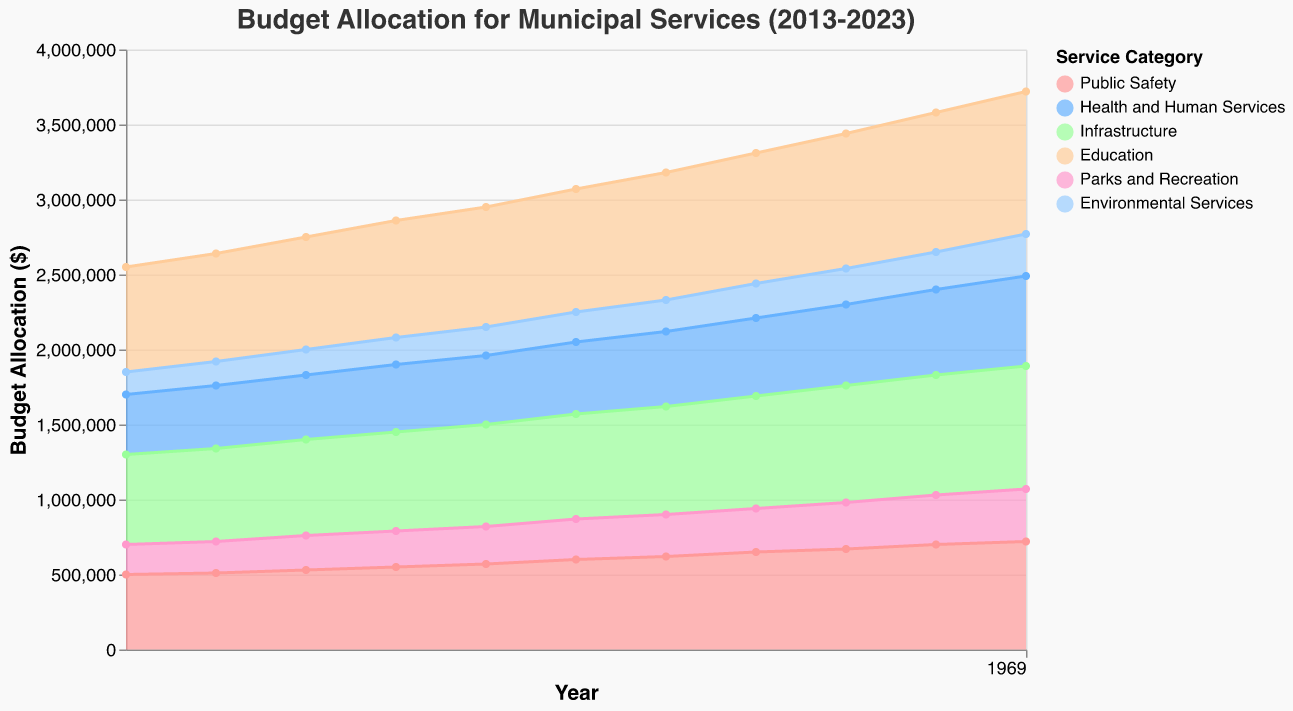What is the title of the figure? The title of the figure is at the top and describes the overall content of the chart. It reads "Budget Allocation for Municipal Services (2013-2023)" which provides context for what the chart represents.
Answer: Budget Allocation for Municipal Services (2013-2023) What are the six categories of services represented in the chart? The legend in the chart details the six different categories being plotted, which are: Public Safety, Health and Human Services, Infrastructure, Education, Parks and Recreation, and Environmental Services.
Answer: Public Safety, Health and Human Services, Infrastructure, Education, Parks and Recreation, Environmental Services In which year does 'Education' have the highest budget? By following the 'Education' area in the chart, it is visible that 'Education' has the largest budget allocation in the year 2023, where its area is maximized.
Answer: 2023 What is the total budget allocation for 'Public Safety' and 'Health and Human Services' in the year 2018? Refer to the values given for 'Public Safety' and 'Health and Human Services' in 2018 and sum them up: $600,000 for 'Public Safety' and $480,000 for 'Health and Human Services'. Therefore, the total allocation is $600,000 + $480,000 = $1,080,000.
Answer: $1,080,000 Which category has the largest budget allocation in 2015? By examining the heights of the different colored areas starting from the y-axis for the year 2015 and moving rightwards, it can be seen that 'Education' (orange color) has the highest area, indicating the largest budget allocation.
Answer: Education How has the budget for 'Environmental Services' changed from 2013 to 2023? By comparing the y-values of the 'Environmental Services' in both years, it is evident that the budget increased from $150,000 in 2013 to $280,000 in 2023. The change is calculated as $280,000 - $150,000 = $130,000.
Answer: Increased by $130,000 Which year shows a sudden increase in budget for 'Parks and Recreation'? Look for a steep rise in the area representing 'Parks and Recreation'. There is a noticeable increase between 2017 and 2018, where the budget jumps from $250,000 to $270,000, showing an increment of $20,000.
Answer: 2018 What is the combined budget allocation for 'Infrastructure' over the decade (2013-2023)? Sum up the budget values for 'Infrastructure' from 2013 to 2023: $600,000 + $620,000 + $640,000 + $660,000 + $680,000 + $700,000 + $720,000 + $750,000 + $780,000 + $800,000 + $820,000. The total combined budget is $7,770,000.
Answer: $7,770,000 During which year does 'Public Safety' overtake 'Health and Human Services' in terms of budget allocation? By observing the crossover point of the 'Public Safety' and 'Health and Human Services' areas, 'Public Safety' consistently had a higher budget allocation compared to 'Health and Human Services' across all years.
Answer: Always 